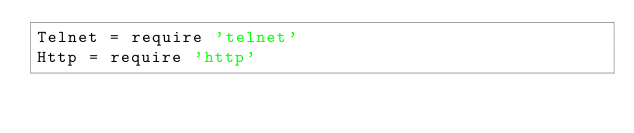Convert code to text. <code><loc_0><loc_0><loc_500><loc_500><_MoonScript_>Telnet = require 'telnet'
Http = require 'http'
</code> 